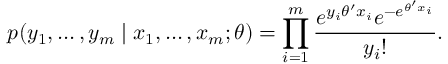<formula> <loc_0><loc_0><loc_500><loc_500>p ( y _ { 1 } , \dots , y _ { m } | x _ { 1 } , \dots , x _ { m } ; \theta ) = \prod _ { i = 1 } ^ { m } { \frac { e ^ { y _ { i } \theta ^ { \prime } x _ { i } } e ^ { - e ^ { \theta ^ { \prime } x _ { i } } } } { y _ { i } ! } } .</formula> 